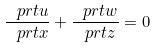Convert formula to latex. <formula><loc_0><loc_0><loc_500><loc_500>\frac { \ p r t u } { \ p r t x } + \frac { \ p r t w } { \ p r t z } = 0</formula> 